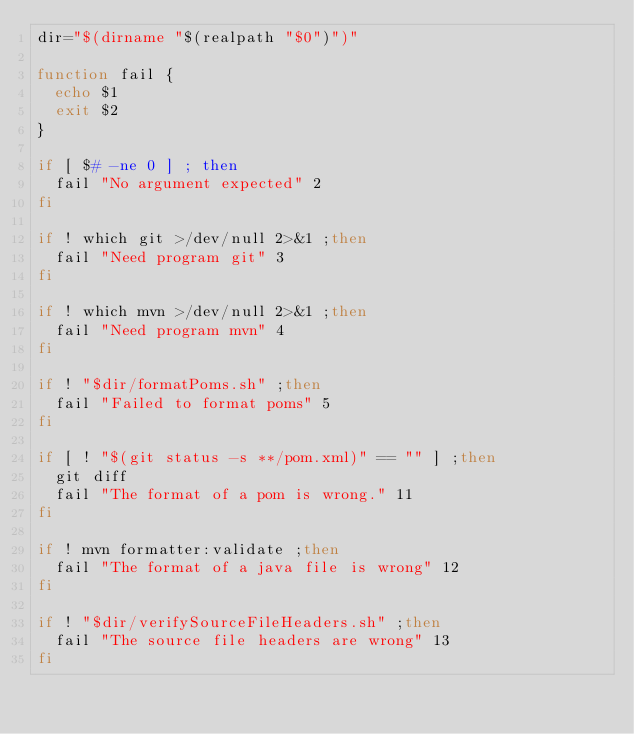Convert code to text. <code><loc_0><loc_0><loc_500><loc_500><_Bash_>dir="$(dirname "$(realpath "$0")")"

function fail {
  echo $1
  exit $2
}

if [ $# -ne 0 ] ; then
  fail "No argument expected" 2
fi

if ! which git >/dev/null 2>&1 ;then
  fail "Need program git" 3
fi

if ! which mvn >/dev/null 2>&1 ;then
  fail "Need program mvn" 4
fi

if ! "$dir/formatPoms.sh" ;then
  fail "Failed to format poms" 5
fi

if [ ! "$(git status -s **/pom.xml)" == "" ] ;then
  git diff
  fail "The format of a pom is wrong." 11
fi

if ! mvn formatter:validate ;then
  fail "The format of a java file is wrong" 12
fi

if ! "$dir/verifySourceFileHeaders.sh" ;then
  fail "The source file headers are wrong" 13
fi
</code> 